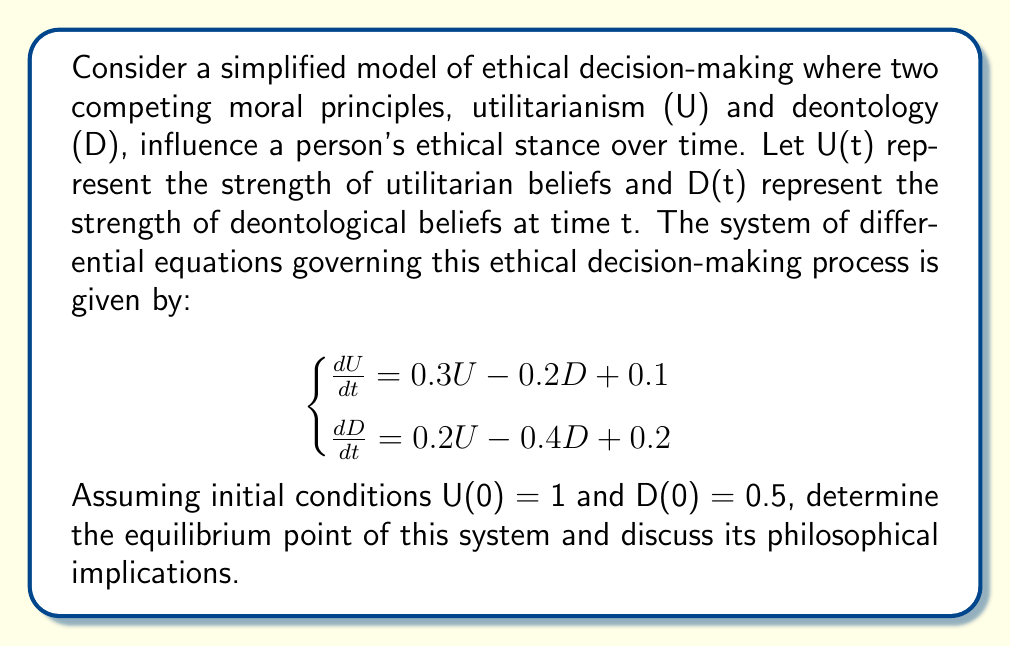Provide a solution to this math problem. To solve this system and find the equilibrium point, we follow these steps:

1) At equilibrium, the rates of change are zero. So, we set both equations to zero:

   $$\begin{cases}
   0 = 0.3U - 0.2D + 0.1 \\
   0 = 0.2U - 0.4D + 0.2
   \end{cases}$$

2) Rearrange the equations:

   $$\begin{cases}
   0.2D = 0.3U + 0.1 \\
   0.4D = 0.2U + 0.2
   \end{cases}$$

3) Multiply the first equation by 2:

   $$\begin{cases}
   0.4D = 0.6U + 0.2 \\
   0.4D = 0.2U + 0.2
   \end{cases}$$

4) Subtract the second equation from the first:

   $$0.4U = 0$$

5) Solve for U:

   $$U = 0$$

6) Substitute this value of U into either of the original equations. Let's use the first one:

   $$0 = 0.3(0) - 0.2D + 0.1$$
   $$0.2D = 0.1$$
   $$D = 0.5$$

7) Therefore, the equilibrium point is (U, D) = (0, 0.5).

Philosophical Implications:
This equilibrium point suggests that in the long term, under this model, an individual's ethical stance would stabilize with a complete absence of utilitarian beliefs (U = 0) and a moderate level of deontological beliefs (D = 0.5). This could be interpreted as a tendency towards rule-based ethics rather than consequence-based ethics in decision-making processes. However, it's crucial to note that this is a simplified model and real ethical decision-making is far more complex, involving numerous other factors and principles.
Answer: Equilibrium point: (U, D) = (0, 0.5) 